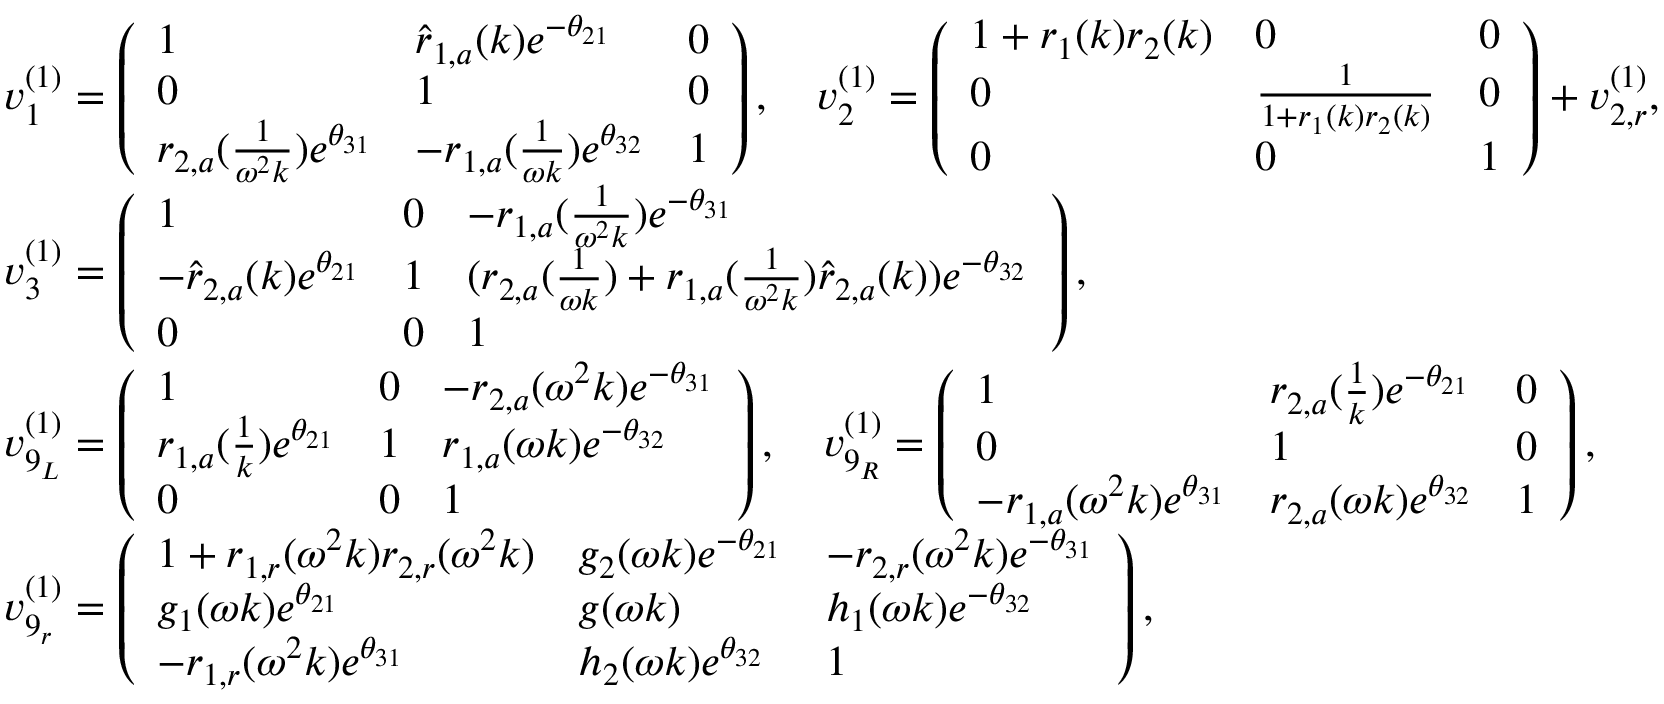<formula> <loc_0><loc_0><loc_500><loc_500>\begin{array} { r l } & { v _ { 1 } ^ { ( 1 ) } = \left ( \begin{array} { l l l } { 1 } & { \hat { r } _ { 1 , a } ( k ) e ^ { - \theta _ { 2 1 } } } & { 0 } \\ { 0 } & { 1 } & { 0 } \\ { r _ { 2 , a } ( \frac { 1 } { \omega ^ { 2 } k } ) e ^ { \theta _ { 3 1 } } } & { - r _ { 1 , a } ( \frac { 1 } { \omega k } ) e ^ { \theta _ { 3 2 } } } & { 1 } \end{array} \right ) , \quad v _ { 2 } ^ { ( 1 ) } = \left ( \begin{array} { l l l } { 1 + r _ { 1 } ( k ) r _ { 2 } ( k ) } & { 0 } & { 0 } \\ { 0 } & { \frac { 1 } { 1 + r _ { 1 } ( k ) r _ { 2 } ( k ) } } & { 0 } \\ { 0 } & { 0 } & { 1 } \end{array} \right ) + v _ { 2 , r } ^ { ( 1 ) } , } \\ & { v _ { 3 } ^ { ( 1 ) } = \left ( \begin{array} { l l l } { 1 } & { 0 } & { - r _ { 1 , a } ( \frac { 1 } { \omega ^ { 2 } k } ) e ^ { - \theta _ { 3 1 } } } \\ { - \hat { r } _ { 2 , a } ( k ) e ^ { \theta _ { 2 1 } } } & { 1 } & { ( r _ { 2 , a } ( \frac { 1 } { \omega k } ) + r _ { 1 , a } ( \frac { 1 } { \omega ^ { 2 } k } ) \hat { r } _ { 2 , a } ( k ) ) e ^ { - \theta _ { 3 2 } } } \\ { 0 } & { 0 } & { 1 } \end{array} \right ) , } \\ & { v _ { 9 _ { L } } ^ { ( 1 ) } = \left ( \begin{array} { l l l } { 1 } & { 0 } & { - r _ { 2 , a } ( \omega ^ { 2 } k ) e ^ { - \theta _ { 3 1 } } } \\ { r _ { 1 , a } ( \frac { 1 } { k } ) e ^ { \theta _ { 2 1 } } } & { 1 } & { r _ { 1 , a } ( \omega k ) e ^ { - \theta _ { 3 2 } } } \\ { 0 } & { 0 } & { 1 } \end{array} \right ) , \quad v _ { 9 _ { R } } ^ { ( 1 ) } = \left ( \begin{array} { l l l } { 1 } & { r _ { 2 , a } ( \frac { 1 } { k } ) e ^ { - \theta _ { 2 1 } } } & { 0 } \\ { 0 } & { 1 } & { 0 } \\ { - r _ { 1 , a } ( \omega ^ { 2 } k ) e ^ { \theta _ { 3 1 } } } & { r _ { 2 , a } ( \omega k ) e ^ { \theta _ { 3 2 } } } & { 1 } \end{array} \right ) , } \\ & { v _ { 9 _ { r } } ^ { ( 1 ) } = \left ( \begin{array} { l l l } { 1 + r _ { 1 , r } ( \omega ^ { 2 } k ) r _ { 2 , r } ( \omega ^ { 2 } k ) } & { g _ { 2 } ( \omega k ) e ^ { - \theta _ { 2 1 } } } & { - r _ { 2 , r } ( \omega ^ { 2 } k ) e ^ { - \theta _ { 3 1 } } } \\ { g _ { 1 } ( \omega k ) e ^ { \theta _ { 2 1 } } } & { g ( \omega k ) } & { h _ { 1 } ( \omega k ) e ^ { - \theta _ { 3 2 } } } \\ { - r _ { 1 , r } ( \omega ^ { 2 } k ) e ^ { \theta _ { 3 1 } } } & { h _ { 2 } ( \omega k ) e ^ { \theta _ { 3 2 } } } & { 1 } \end{array} \right ) , } \end{array}</formula> 